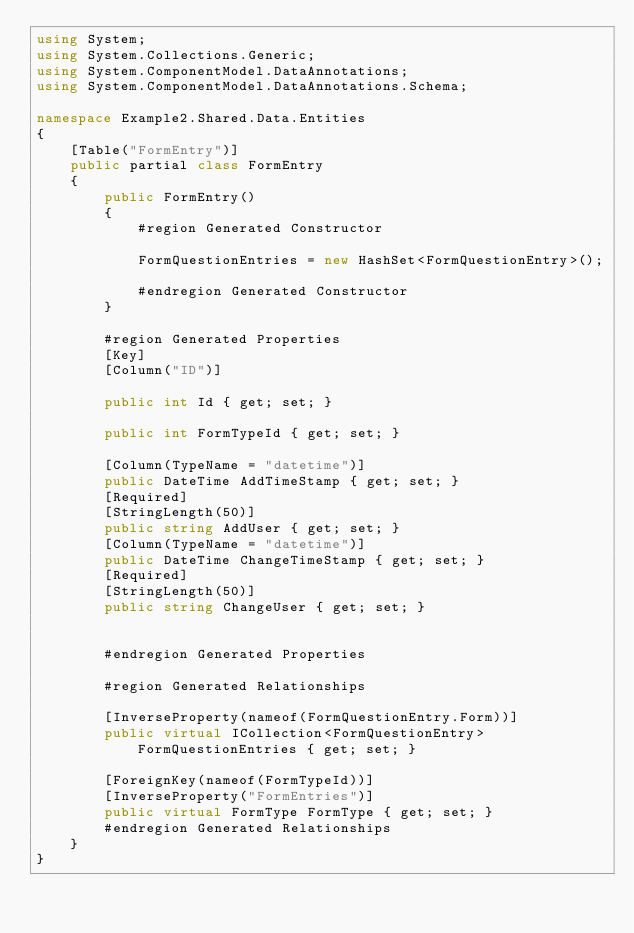Convert code to text. <code><loc_0><loc_0><loc_500><loc_500><_C#_>using System;
using System.Collections.Generic;
using System.ComponentModel.DataAnnotations;
using System.ComponentModel.DataAnnotations.Schema;

namespace Example2.Shared.Data.Entities
{
    [Table("FormEntry")]
    public partial class FormEntry
    {
        public FormEntry()
        {
            #region Generated Constructor

            FormQuestionEntries = new HashSet<FormQuestionEntry>();

            #endregion Generated Constructor
        }

        #region Generated Properties
        [Key]
        [Column("ID")]

        public int Id { get; set; }

        public int FormTypeId { get; set; }

        [Column(TypeName = "datetime")]
        public DateTime AddTimeStamp { get; set; }
        [Required]
        [StringLength(50)]
        public string AddUser { get; set; }
        [Column(TypeName = "datetime")]
        public DateTime ChangeTimeStamp { get; set; }
        [Required]
        [StringLength(50)]
        public string ChangeUser { get; set; }


        #endregion Generated Properties

        #region Generated Relationships

        [InverseProperty(nameof(FormQuestionEntry.Form))]
        public virtual ICollection<FormQuestionEntry> FormQuestionEntries { get; set; }

        [ForeignKey(nameof(FormTypeId))]
        [InverseProperty("FormEntries")]
        public virtual FormType FormType { get; set; }
        #endregion Generated Relationships
    }
}</code> 